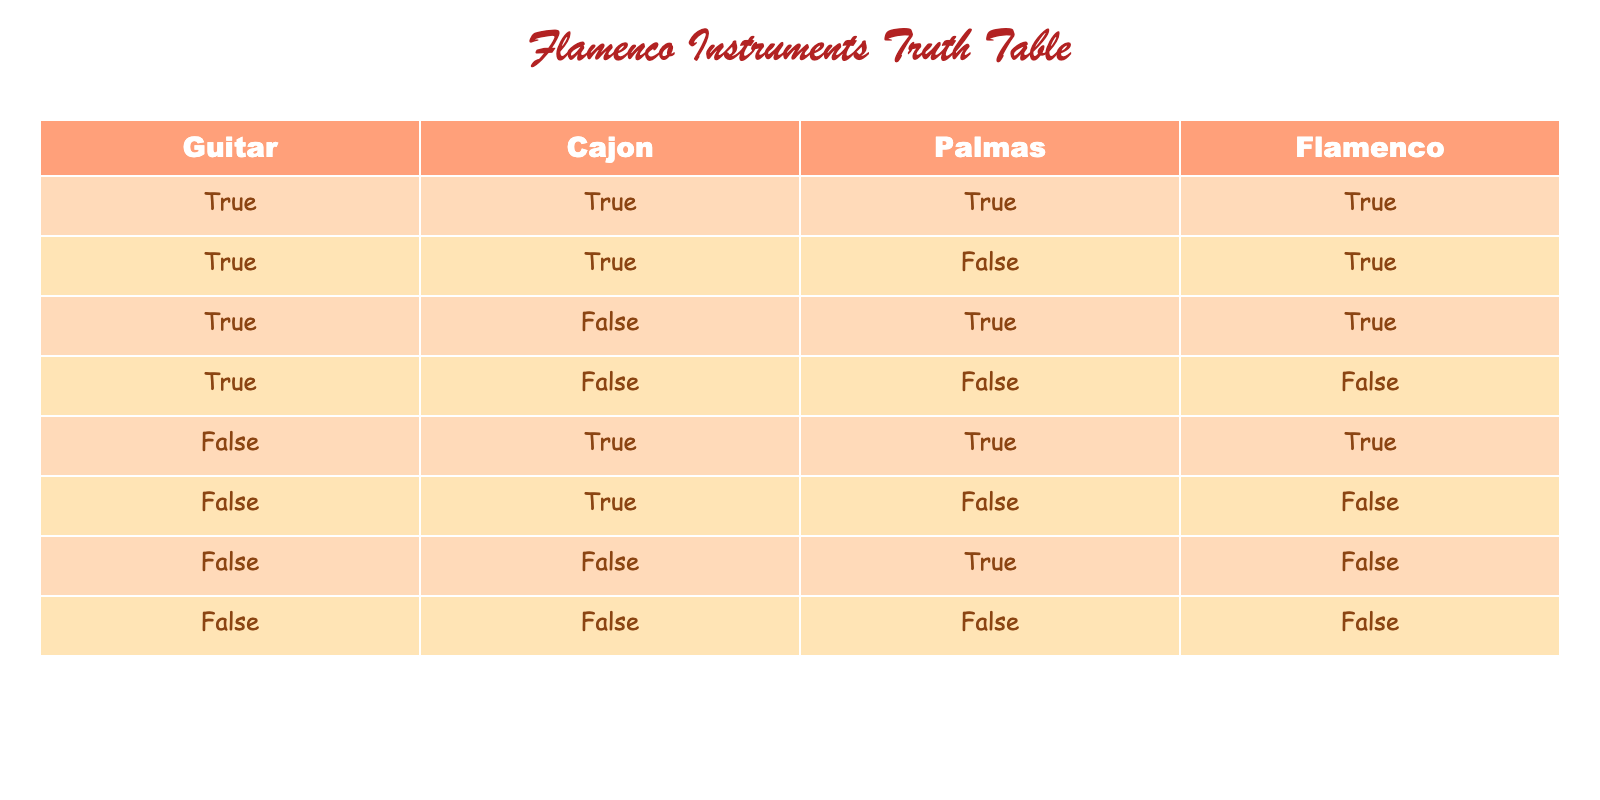What combination of instruments results in a "Flamenco" performance? The "Flamenco" column is true (✓) when the combinations include either Guitar and Cajon with Palmas, or only Guitar and Cajon. Rows 1, 2, and 3 indicate a true result.
Answer: Guitar, Cajon, Palmas Is it true that the presence of Cajon and Palmas always means the performance is Flamenco? No, it's not true. While Cajon and Palmas are present in some true Flamenco rows, Guitar is necessary to confirm the performance type; specifically, rows with just Cajon and Palmas (rows 5 and 6) do not equal Flamenco.
Answer: No How many different combinations include the Guitar? There are 4 rows where the Guitar is present (rows 1, 2, 3, and 4).
Answer: 4 What is the average number of true instruments (Guitar, Cajon, Palmas) present in a Flamenco performance? To find the average, first, count the true values per row in Flamenco performances (1. 3 true, 2. 2 true, 3. 2 true) sum them, and divide by 3 (for the 3 rows). (3 + 2 + 2) / 3 = 2.33
Answer: 2.33 Is there ever a case where Palmas is true but Flamenco is false? Yes, in row 7, Palmas is true, but Flamenco is false. This shows that Palmas alone does not guarantee a Flamenco performance.
Answer: Yes 